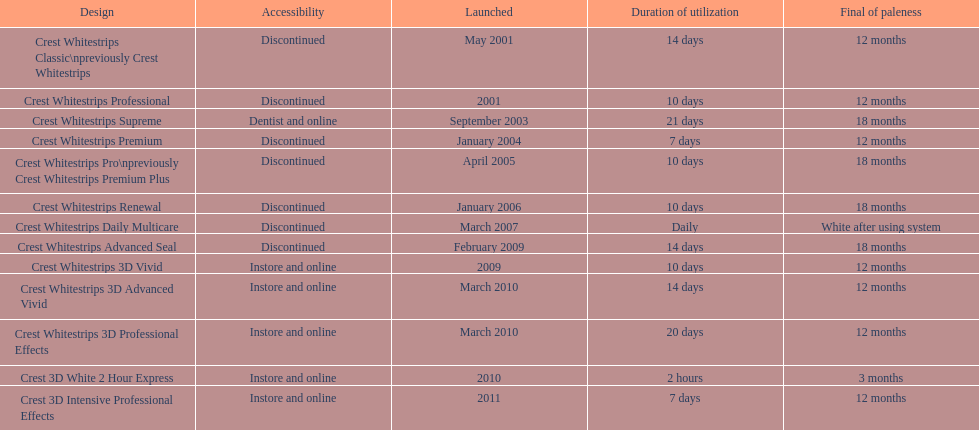How many models require less than a week of use? 2. 